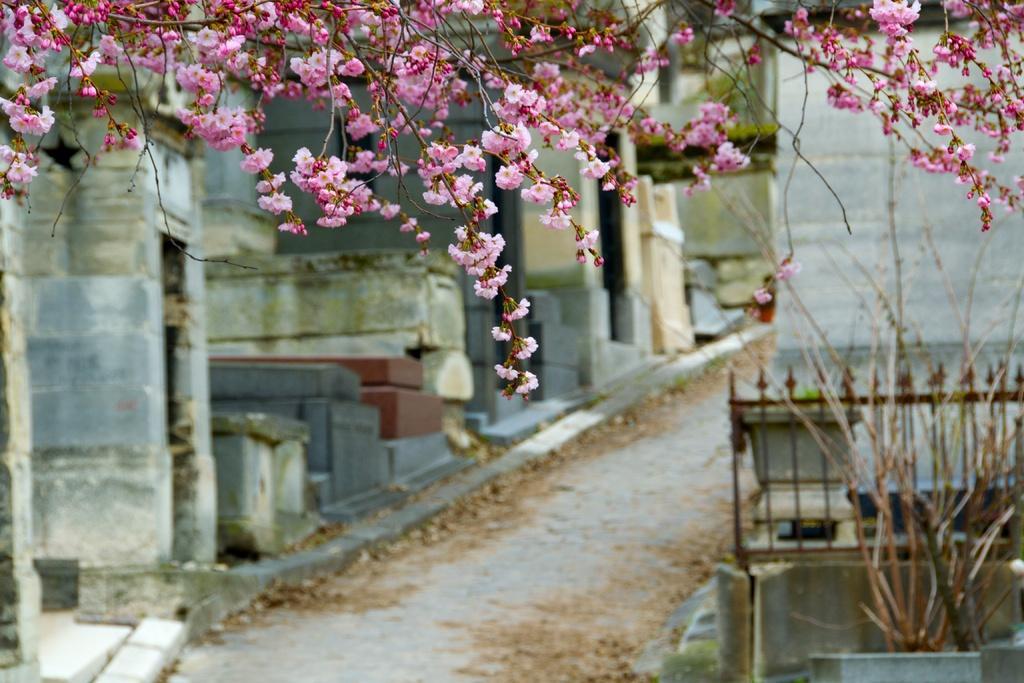How would you summarize this image in a sentence or two? At the top of this image, there is a tree having pink color flowers. In the background, there is a road. On the left side of this road, there are buildings. On the right side of this road, there is a building, there is a fence and there is a dry plant. 